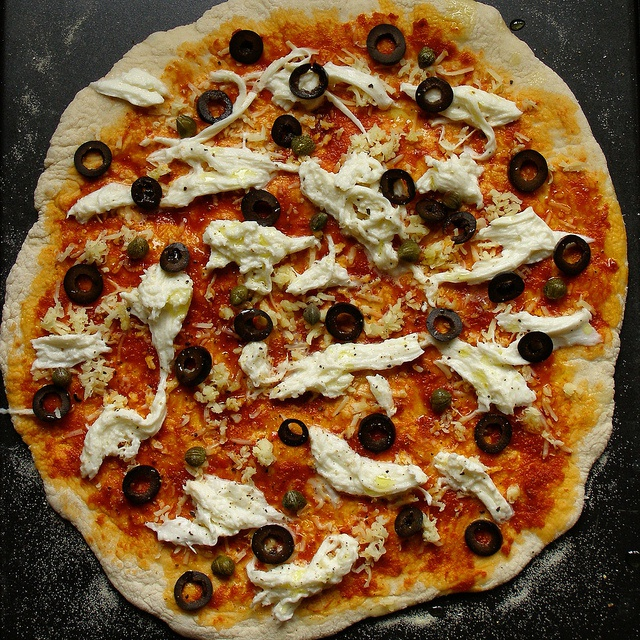Describe the objects in this image and their specific colors. I can see pizza in black, red, maroon, and tan tones and dining table in black, gray, and tan tones in this image. 